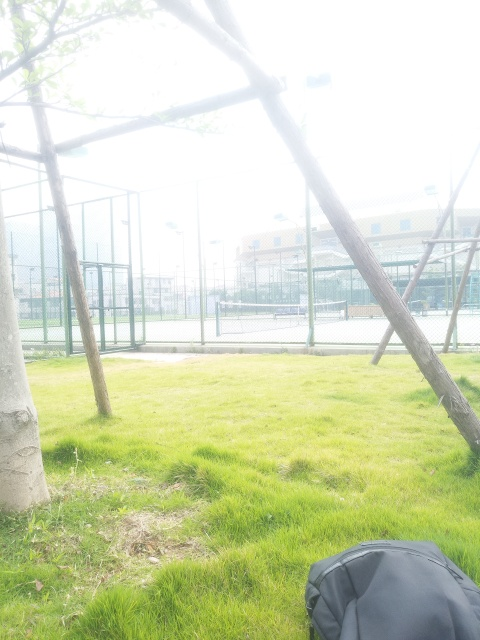Can you describe the setting of this location? This location appears to be an urban park with recreational facilities. There's a grassy area with some trees and a fence enclosing what looks like a set of sports courts, possibly for tennis or basketball. The presence of the backpack suggests someone is engaged in outdoor activities, perhaps taking a break nearby. 